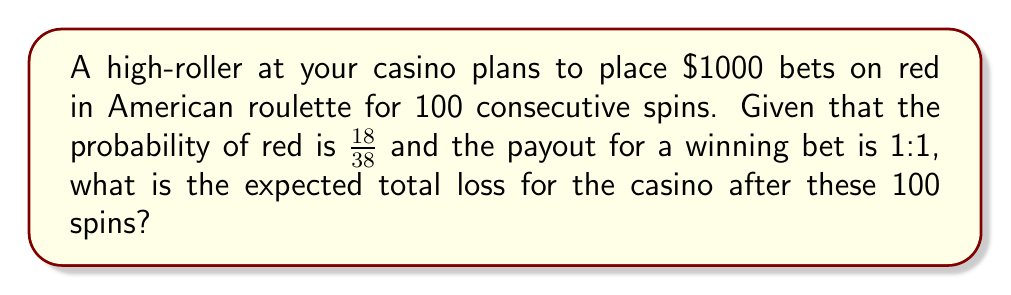Can you solve this math problem? Let's approach this step-by-step:

1) First, we need to calculate the expected value of a single bet:

   a) Probability of winning (red): $P(\text{win}) = \frac{18}{38}$
   b) Probability of losing (not red): $P(\text{lose}) = 1 - \frac{18}{38} = \frac{20}{38}$
   c) Payout for winning: 1:1, meaning the player gets their $1000 back plus an additional $1000
   d) For a $1000 bet, the expected value is:

   $$E = 1000 \cdot \frac{18}{38} + (-1000) \cdot \frac{20}{38} = -\frac{2000}{38} \approx -52.63$$

2) This means that on average, the casino expects to win $52.63 per spin.

3) For 100 spins, we multiply this expected value by 100:

   $$E_{100} = 100 \cdot (-\frac{2000}{38}) = -\frac{200000}{38} \approx -5263.16$$

4) The negative sign indicates a loss for the player, which is a gain for the casino.

Therefore, the expected total gain for the casino (or loss for the player) after 100 spins is $5263.16.
Answer: $5263.16 